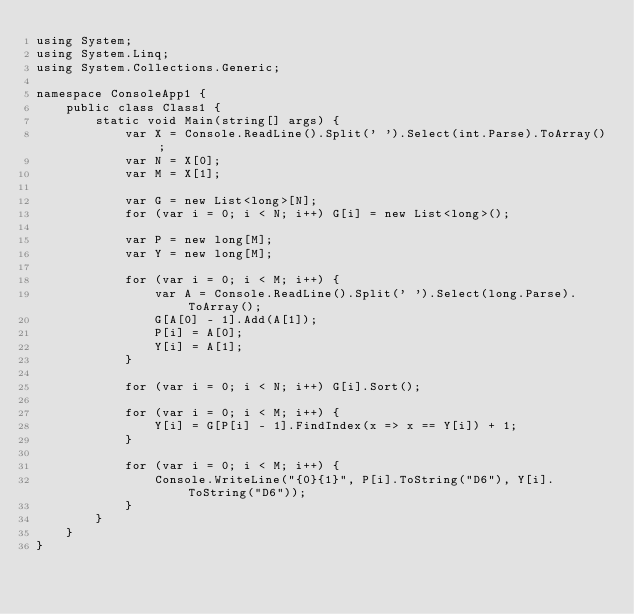Convert code to text. <code><loc_0><loc_0><loc_500><loc_500><_C#_>using System;
using System.Linq;
using System.Collections.Generic;

namespace ConsoleApp1 {
    public class Class1 {
        static void Main(string[] args) {
            var X = Console.ReadLine().Split(' ').Select(int.Parse).ToArray();
            var N = X[0];
            var M = X[1];

            var G = new List<long>[N];
            for (var i = 0; i < N; i++) G[i] = new List<long>();

            var P = new long[M];
            var Y = new long[M];

            for (var i = 0; i < M; i++) {
                var A = Console.ReadLine().Split(' ').Select(long.Parse).ToArray();
                G[A[0] - 1].Add(A[1]);
                P[i] = A[0];
                Y[i] = A[1];
            }

            for (var i = 0; i < N; i++) G[i].Sort();

            for (var i = 0; i < M; i++) {
                Y[i] = G[P[i] - 1].FindIndex(x => x == Y[i]) + 1;
            }

            for (var i = 0; i < M; i++) {
                Console.WriteLine("{0}{1}", P[i].ToString("D6"), Y[i].ToString("D6"));
            }
        }
    }
}</code> 